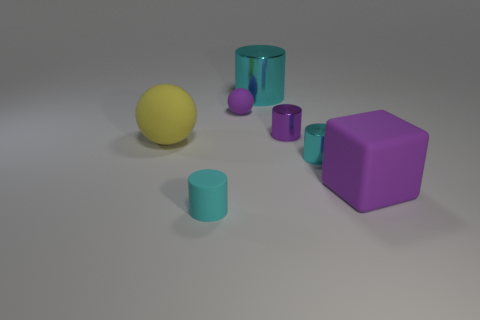Subtract all yellow cubes. How many cyan cylinders are left? 3 Subtract 1 cylinders. How many cylinders are left? 3 Add 1 yellow matte balls. How many objects exist? 8 Subtract all cylinders. How many objects are left? 3 Subtract 0 yellow blocks. How many objects are left? 7 Subtract all tiny red cubes. Subtract all tiny purple spheres. How many objects are left? 6 Add 6 cyan cylinders. How many cyan cylinders are left? 9 Add 5 big rubber spheres. How many big rubber spheres exist? 6 